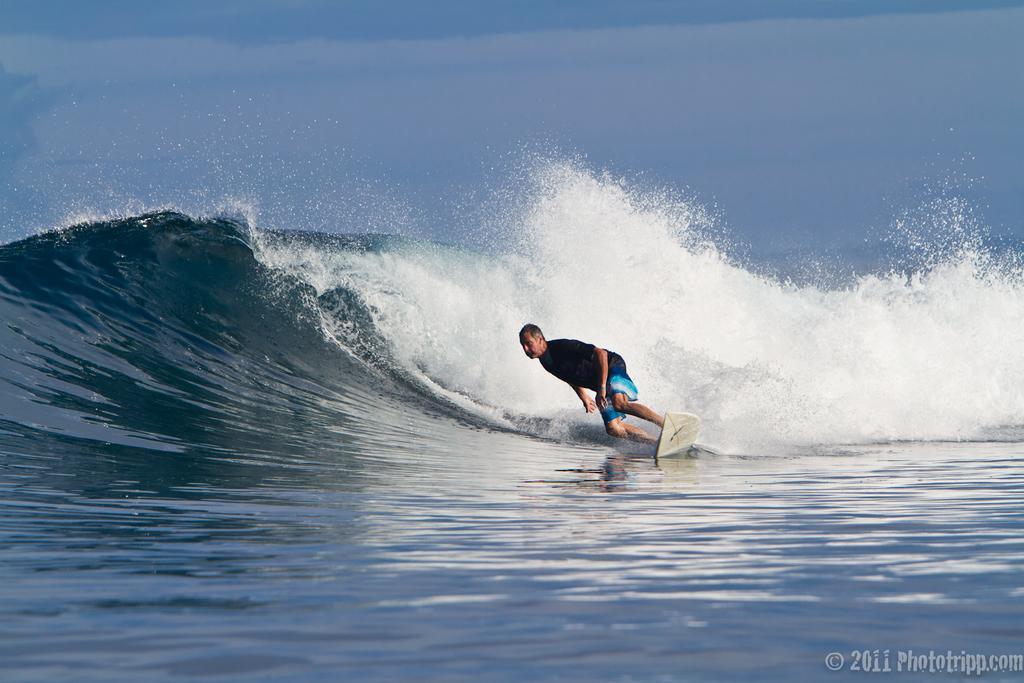Can you describe this image briefly? This picture is clicked outside the city. In the center there is a person surfing on the surfboard. In the background we can see the ripples in the water body. At the bottom right corner there is a watermark on the image. 